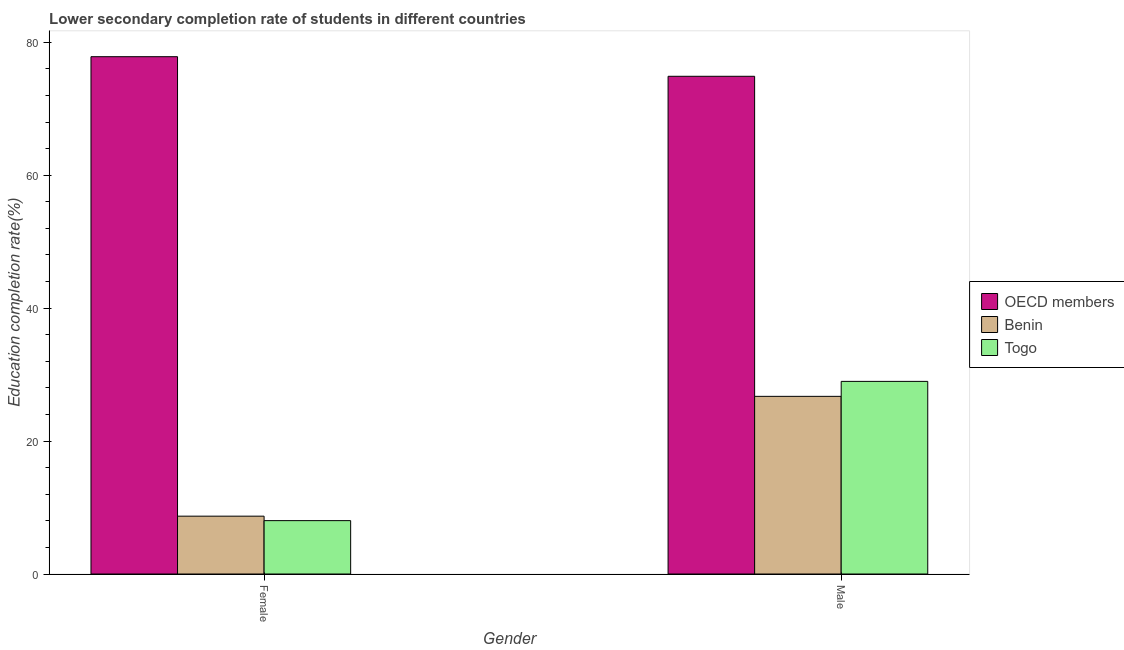How many bars are there on the 1st tick from the right?
Your response must be concise. 3. What is the label of the 1st group of bars from the left?
Your answer should be compact. Female. What is the education completion rate of male students in Togo?
Your answer should be compact. 28.98. Across all countries, what is the maximum education completion rate of female students?
Your answer should be very brief. 77.83. Across all countries, what is the minimum education completion rate of male students?
Provide a short and direct response. 26.73. In which country was the education completion rate of male students minimum?
Keep it short and to the point. Benin. What is the total education completion rate of male students in the graph?
Keep it short and to the point. 130.6. What is the difference between the education completion rate of male students in Togo and that in Benin?
Ensure brevity in your answer.  2.25. What is the difference between the education completion rate of male students in Togo and the education completion rate of female students in Benin?
Your answer should be very brief. 20.28. What is the average education completion rate of female students per country?
Your response must be concise. 31.52. What is the difference between the education completion rate of male students and education completion rate of female students in Benin?
Give a very brief answer. 18.03. In how many countries, is the education completion rate of male students greater than 8 %?
Your response must be concise. 3. What is the ratio of the education completion rate of male students in OECD members to that in Togo?
Keep it short and to the point. 2.58. In how many countries, is the education completion rate of male students greater than the average education completion rate of male students taken over all countries?
Your response must be concise. 1. What does the 1st bar from the right in Female represents?
Make the answer very short. Togo. Are all the bars in the graph horizontal?
Make the answer very short. No. How many countries are there in the graph?
Give a very brief answer. 3. Are the values on the major ticks of Y-axis written in scientific E-notation?
Your answer should be compact. No. Where does the legend appear in the graph?
Offer a terse response. Center right. How many legend labels are there?
Provide a short and direct response. 3. How are the legend labels stacked?
Make the answer very short. Vertical. What is the title of the graph?
Offer a terse response. Lower secondary completion rate of students in different countries. Does "Faeroe Islands" appear as one of the legend labels in the graph?
Provide a short and direct response. No. What is the label or title of the X-axis?
Your answer should be very brief. Gender. What is the label or title of the Y-axis?
Keep it short and to the point. Education completion rate(%). What is the Education completion rate(%) of OECD members in Female?
Make the answer very short. 77.83. What is the Education completion rate(%) of Benin in Female?
Offer a very short reply. 8.7. What is the Education completion rate(%) of Togo in Female?
Make the answer very short. 8.03. What is the Education completion rate(%) of OECD members in Male?
Provide a succinct answer. 74.88. What is the Education completion rate(%) in Benin in Male?
Offer a very short reply. 26.73. What is the Education completion rate(%) in Togo in Male?
Offer a terse response. 28.98. Across all Gender, what is the maximum Education completion rate(%) of OECD members?
Provide a succinct answer. 77.83. Across all Gender, what is the maximum Education completion rate(%) in Benin?
Offer a terse response. 26.73. Across all Gender, what is the maximum Education completion rate(%) of Togo?
Give a very brief answer. 28.98. Across all Gender, what is the minimum Education completion rate(%) of OECD members?
Your response must be concise. 74.88. Across all Gender, what is the minimum Education completion rate(%) in Benin?
Your response must be concise. 8.7. Across all Gender, what is the minimum Education completion rate(%) of Togo?
Offer a very short reply. 8.03. What is the total Education completion rate(%) in OECD members in the graph?
Make the answer very short. 152.72. What is the total Education completion rate(%) of Benin in the graph?
Your response must be concise. 35.43. What is the total Education completion rate(%) of Togo in the graph?
Provide a succinct answer. 37.01. What is the difference between the Education completion rate(%) in OECD members in Female and that in Male?
Provide a succinct answer. 2.95. What is the difference between the Education completion rate(%) of Benin in Female and that in Male?
Offer a terse response. -18.03. What is the difference between the Education completion rate(%) in Togo in Female and that in Male?
Your response must be concise. -20.95. What is the difference between the Education completion rate(%) in OECD members in Female and the Education completion rate(%) in Benin in Male?
Ensure brevity in your answer.  51.11. What is the difference between the Education completion rate(%) in OECD members in Female and the Education completion rate(%) in Togo in Male?
Provide a succinct answer. 48.85. What is the difference between the Education completion rate(%) of Benin in Female and the Education completion rate(%) of Togo in Male?
Give a very brief answer. -20.28. What is the average Education completion rate(%) in OECD members per Gender?
Provide a succinct answer. 76.36. What is the average Education completion rate(%) of Benin per Gender?
Keep it short and to the point. 17.72. What is the average Education completion rate(%) in Togo per Gender?
Your answer should be very brief. 18.51. What is the difference between the Education completion rate(%) of OECD members and Education completion rate(%) of Benin in Female?
Keep it short and to the point. 69.13. What is the difference between the Education completion rate(%) in OECD members and Education completion rate(%) in Togo in Female?
Ensure brevity in your answer.  69.81. What is the difference between the Education completion rate(%) in Benin and Education completion rate(%) in Togo in Female?
Your answer should be very brief. 0.67. What is the difference between the Education completion rate(%) in OECD members and Education completion rate(%) in Benin in Male?
Make the answer very short. 48.16. What is the difference between the Education completion rate(%) in OECD members and Education completion rate(%) in Togo in Male?
Keep it short and to the point. 45.9. What is the difference between the Education completion rate(%) of Benin and Education completion rate(%) of Togo in Male?
Give a very brief answer. -2.25. What is the ratio of the Education completion rate(%) in OECD members in Female to that in Male?
Provide a succinct answer. 1.04. What is the ratio of the Education completion rate(%) in Benin in Female to that in Male?
Keep it short and to the point. 0.33. What is the ratio of the Education completion rate(%) in Togo in Female to that in Male?
Keep it short and to the point. 0.28. What is the difference between the highest and the second highest Education completion rate(%) of OECD members?
Ensure brevity in your answer.  2.95. What is the difference between the highest and the second highest Education completion rate(%) of Benin?
Your response must be concise. 18.03. What is the difference between the highest and the second highest Education completion rate(%) of Togo?
Offer a very short reply. 20.95. What is the difference between the highest and the lowest Education completion rate(%) in OECD members?
Your answer should be very brief. 2.95. What is the difference between the highest and the lowest Education completion rate(%) in Benin?
Provide a short and direct response. 18.03. What is the difference between the highest and the lowest Education completion rate(%) of Togo?
Provide a short and direct response. 20.95. 